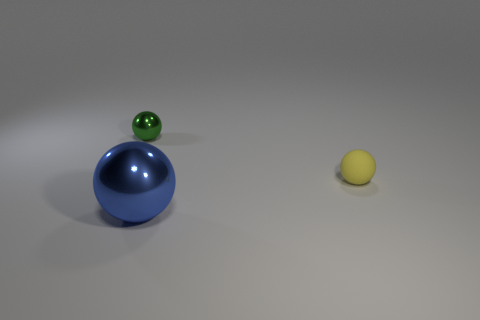Is the number of tiny yellow things that are in front of the blue ball greater than the number of tiny brown rubber cylinders?
Make the answer very short. No. How many other things are the same size as the matte object?
Keep it short and to the point. 1. What number of tiny balls are in front of the large blue ball?
Make the answer very short. 0. Are there an equal number of tiny green metallic spheres on the right side of the tiny yellow matte thing and large metallic objects that are on the left side of the green sphere?
Provide a succinct answer. Yes. The other yellow thing that is the same shape as the small shiny thing is what size?
Give a very brief answer. Small. What is the shape of the shiny thing behind the large thing?
Make the answer very short. Sphere. Is the small sphere to the right of the small green shiny object made of the same material as the object that is behind the tiny yellow thing?
Ensure brevity in your answer.  No. What shape is the blue object?
Offer a very short reply. Sphere. Are there an equal number of big blue metallic objects that are in front of the large blue shiny ball and tiny yellow rubber spheres?
Provide a short and direct response. No. Are there any blue things that have the same material as the yellow thing?
Your answer should be compact. No. 